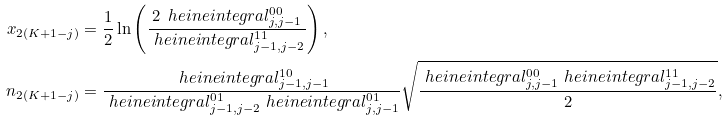Convert formula to latex. <formula><loc_0><loc_0><loc_500><loc_500>x _ { 2 ( K + 1 - j ) } & = \frac { 1 } { 2 } \ln \left ( \frac { 2 \, \ h e i n e i n t e g r a l _ { j , j - 1 } ^ { 0 0 } } { \ h e i n e i n t e g r a l _ { j - 1 , j - 2 } ^ { 1 1 } } \right ) , \\ n _ { 2 ( K + 1 - j ) } & = \frac { \ h e i n e i n t e g r a l _ { j - 1 , j - 1 } ^ { 1 0 } } { \ h e i n e i n t e g r a l _ { j - 1 , j - 2 } ^ { 0 1 } \ h e i n e i n t e g r a l _ { j , j - 1 } ^ { 0 1 } } \sqrt { \frac { \ h e i n e i n t e g r a l _ { j , j - 1 } ^ { 0 0 } \ h e i n e i n t e g r a l _ { j - 1 , j - 2 } ^ { 1 1 } } { 2 } } ,</formula> 